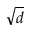<formula> <loc_0><loc_0><loc_500><loc_500>\sqrt { d }</formula> 